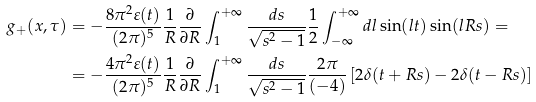<formula> <loc_0><loc_0><loc_500><loc_500>g _ { + } ( x , \tau ) & = - \frac { 8 \pi ^ { 2 } \varepsilon ( t ) } { ( 2 \pi ) ^ { 5 } } \frac { 1 } { R } \frac { \partial } { \partial R } \int _ { 1 } ^ { + \infty } \frac { d s } { \sqrt { s ^ { 2 } - 1 } } \frac { 1 } { 2 } \int _ { - \infty } ^ { + \infty } d l \sin ( l t ) \sin ( l R s ) = \\ & = - \frac { 4 \pi ^ { 2 } \varepsilon ( t ) } { ( 2 \pi ) ^ { 5 } } \frac { 1 } { R } \frac { \partial } { \partial R } \int _ { 1 } ^ { + \infty } \frac { d s } { \sqrt { s ^ { 2 } - 1 } } \frac { 2 \pi } { ( - 4 ) } \left [ 2 \delta ( t + R s ) - 2 \delta ( t - R s ) \right ]</formula> 